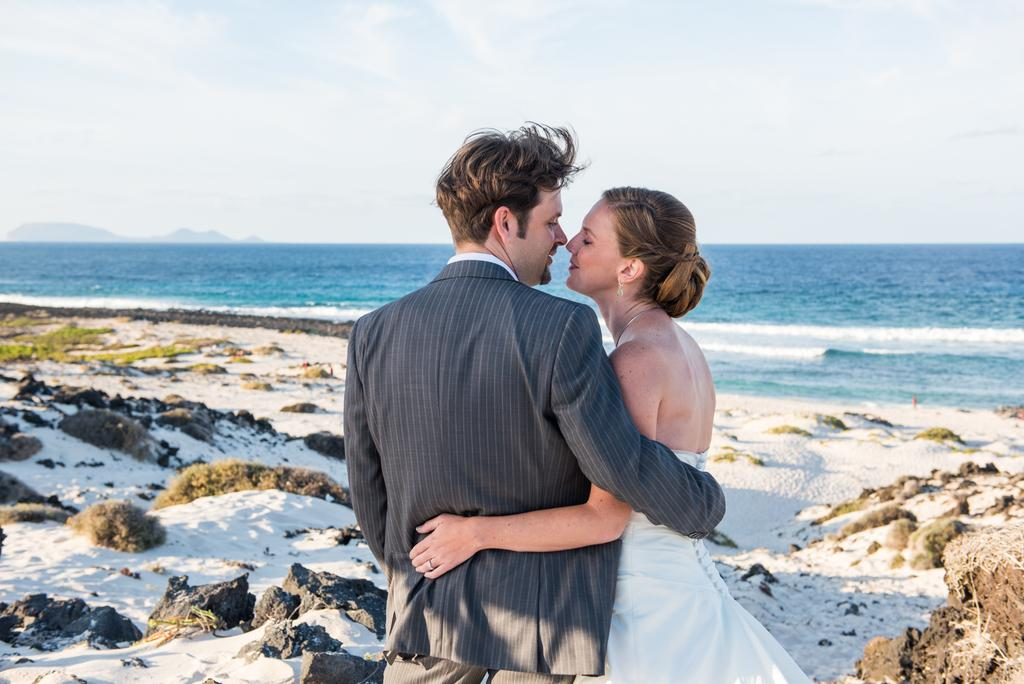What are the two people in the image wearing? The woman is wearing a white dress, and the man is wearing a suit. What are the two people in the image doing? The woman and man are hugging each other. What can be seen in the background of the image? There is a sea, stones, sand, grass, and the sky visible in the background of the image. What time of day does the shocking religious event occur in the image? There is no shocking religious event or specific time of day mentioned in the image. 